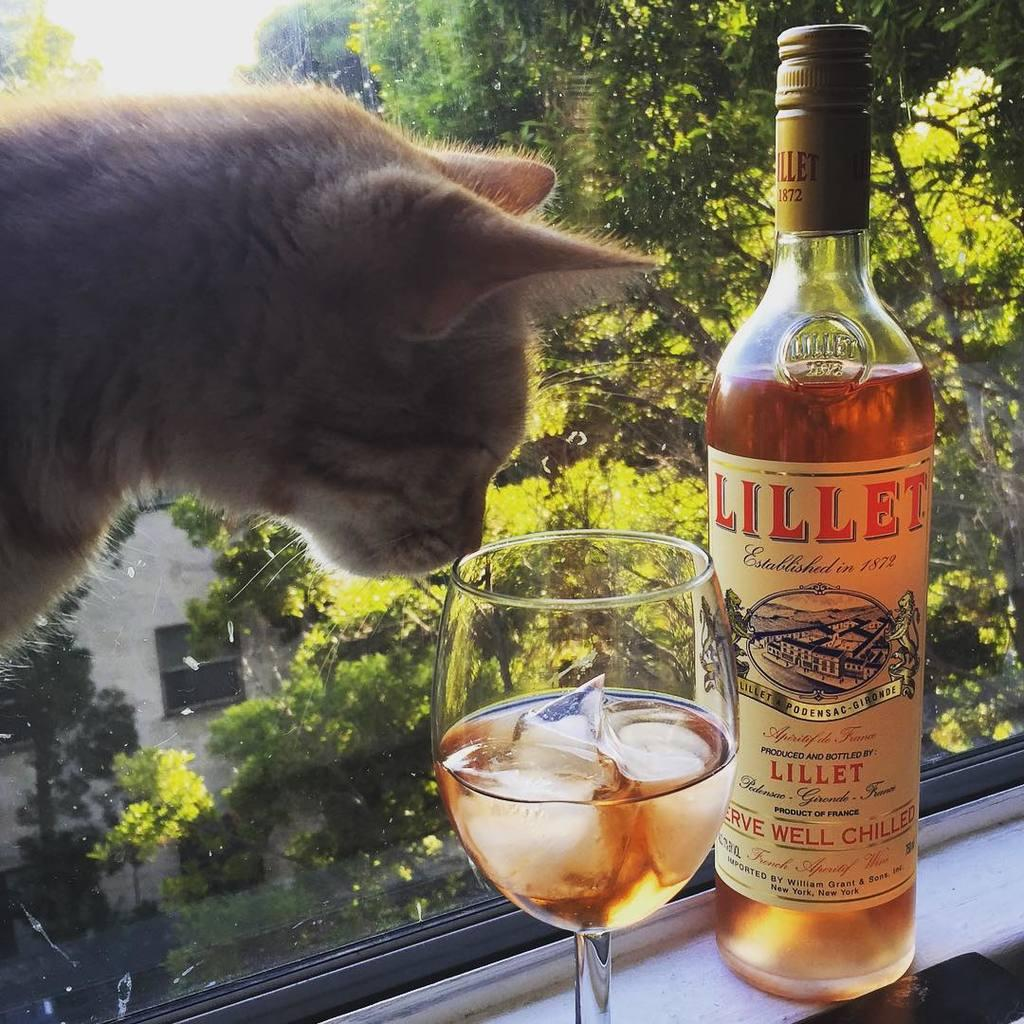<image>
Give a short and clear explanation of the subsequent image. A cat is near a glass of wine that is near a bottle of Lillet wine. 